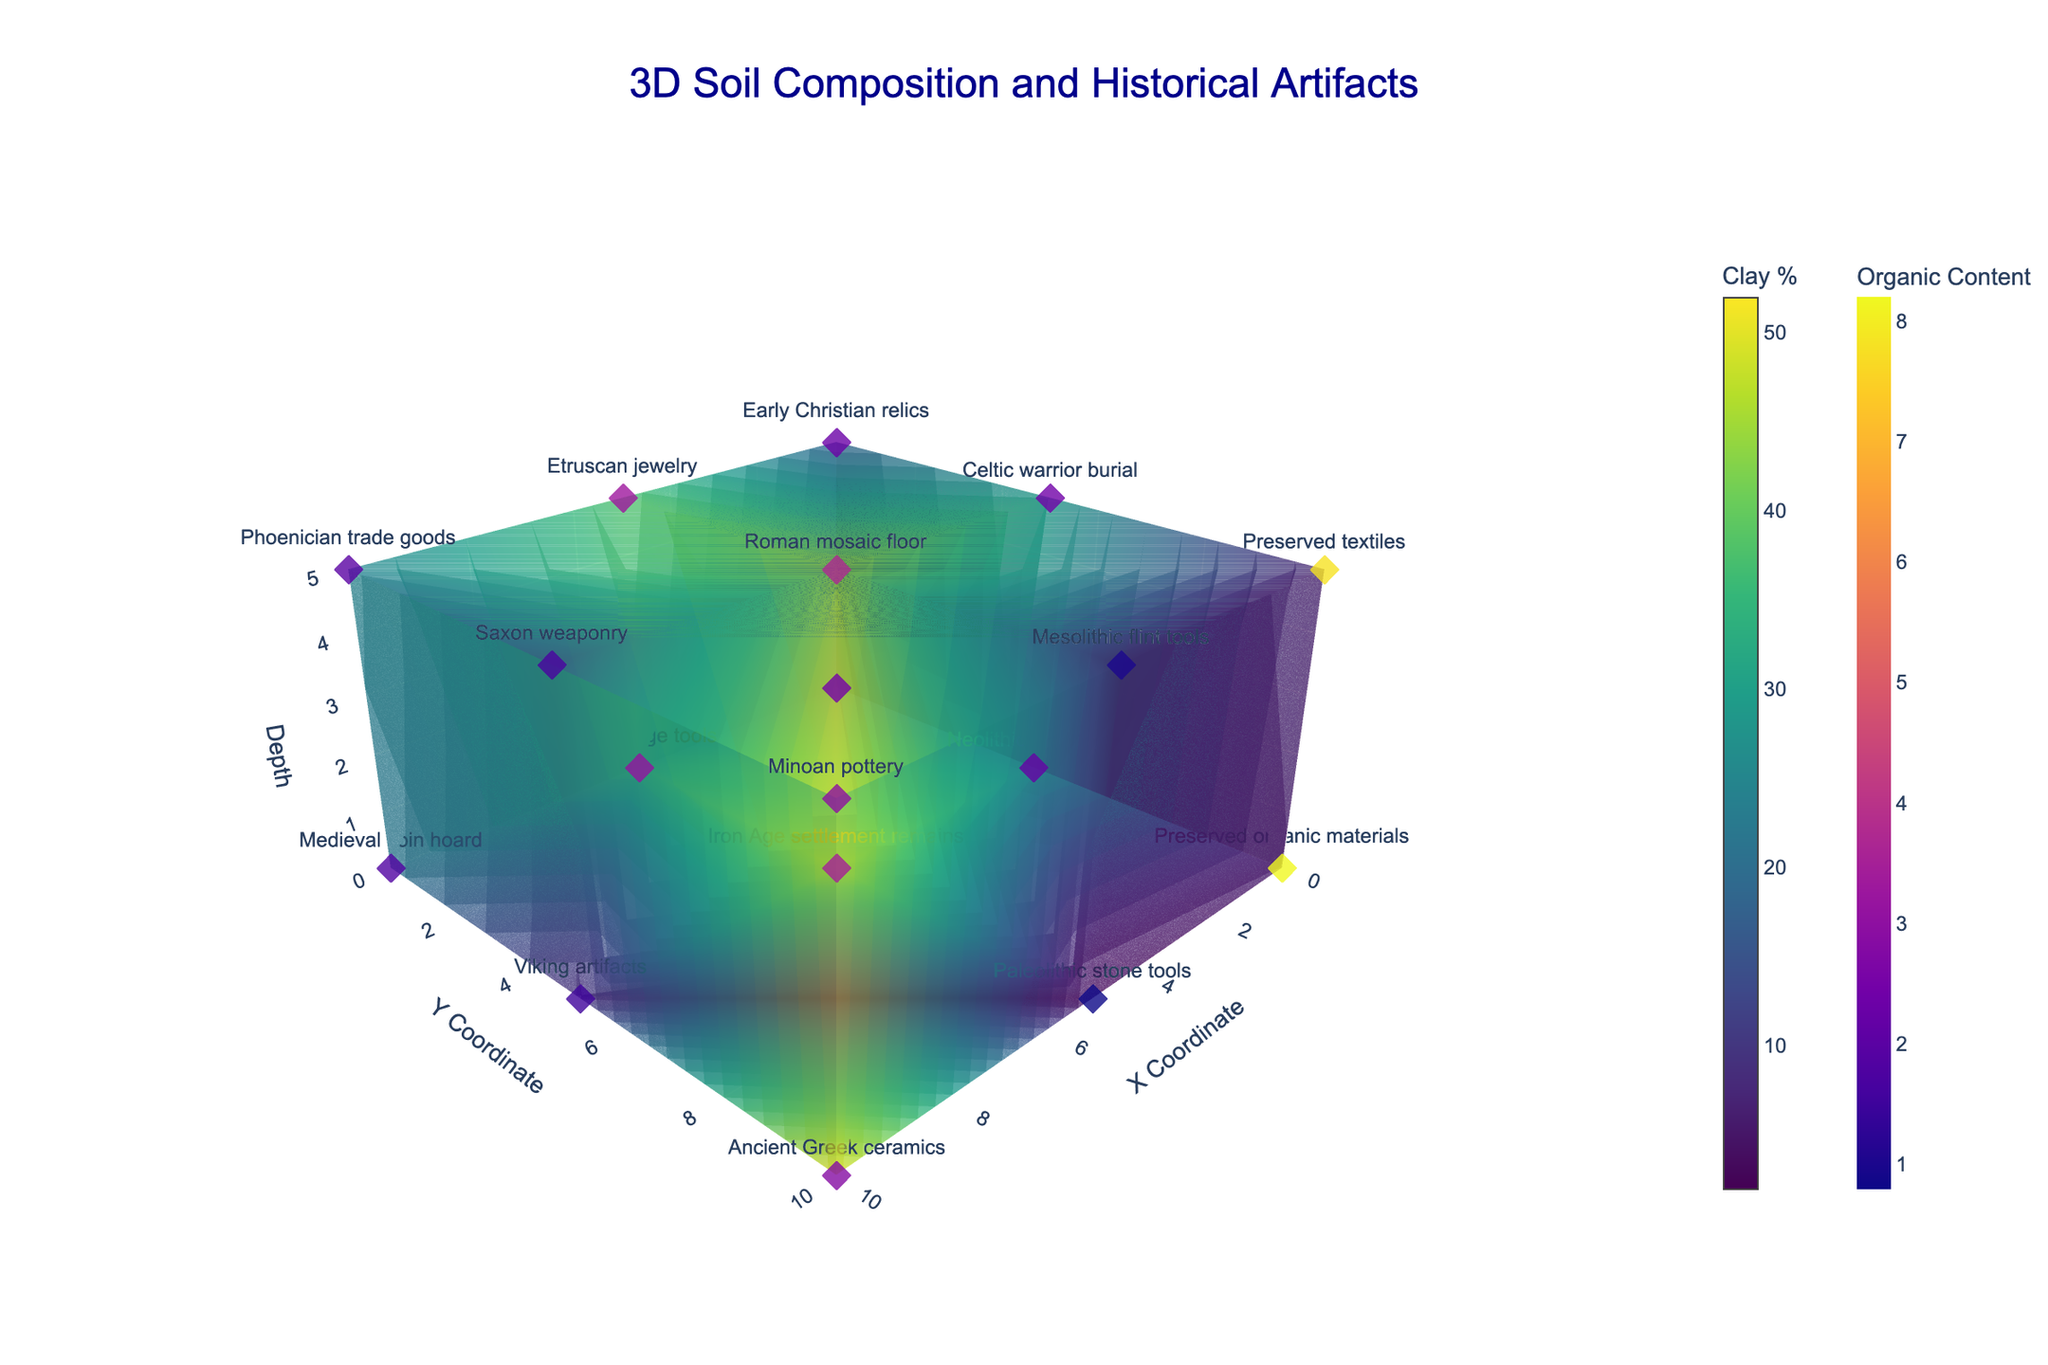What is the title of the 3D plot? The title of the plot is prominently displayed at the top center part of the figure.
Answer: 3D Soil Composition and Historical Artifacts How many data points are indicated in the figure? Count the number of markers representing data points in the 3D scatter plot. Each marker corresponds to a unique (x, y, z) coordinate.
Answer: 18 Which historical artifact is found at the highest clay percentage? Identify the point with the highest color intensity on the clay percentage color scale (Viridis), then check the text of the corresponding marker.
Answer: Minoan pottery What type of soil at coordinates (5, 10, 0) and its pH value? Find the marker located at (5, 10, 0) and read its hover text to determine the soil type and pH value.
Answer: Chalk, pH 8.1 What is the range (min to max) of organic content values displayed in the figure? Look at the color bar titled "Organic Content" on the right. The scale indicates the range of organic content values.
Answer: 0.8 to 8.2 Which historical artifact is found at the coordinate (5, 5, 5)? Locate the marker at (5, 5, 5) in the 3D figure and observe its corresponding hover text to identify the historical artifact.
Answer: Roman mosaic floor 